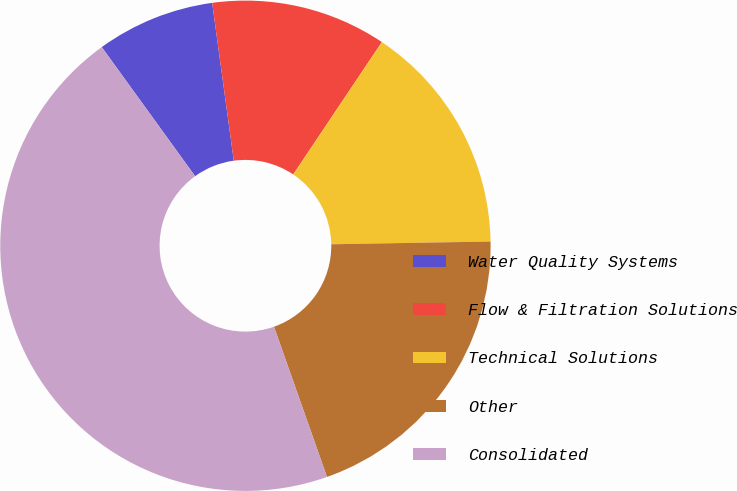Convert chart. <chart><loc_0><loc_0><loc_500><loc_500><pie_chart><fcel>Water Quality Systems<fcel>Flow & Filtration Solutions<fcel>Technical Solutions<fcel>Other<fcel>Consolidated<nl><fcel>7.8%<fcel>11.56%<fcel>15.33%<fcel>19.88%<fcel>45.43%<nl></chart> 